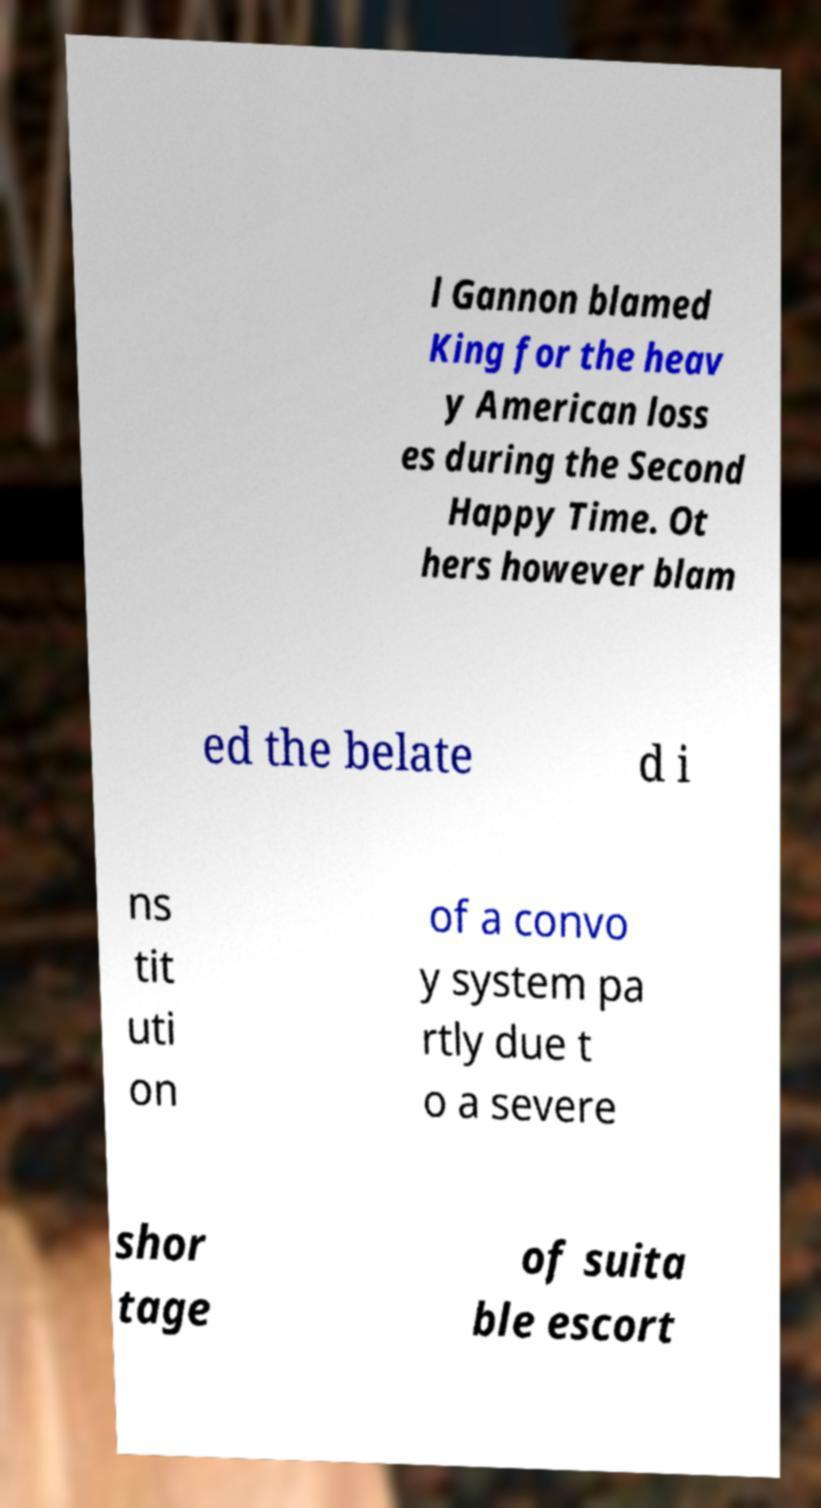Could you assist in decoding the text presented in this image and type it out clearly? l Gannon blamed King for the heav y American loss es during the Second Happy Time. Ot hers however blam ed the belate d i ns tit uti on of a convo y system pa rtly due t o a severe shor tage of suita ble escort 